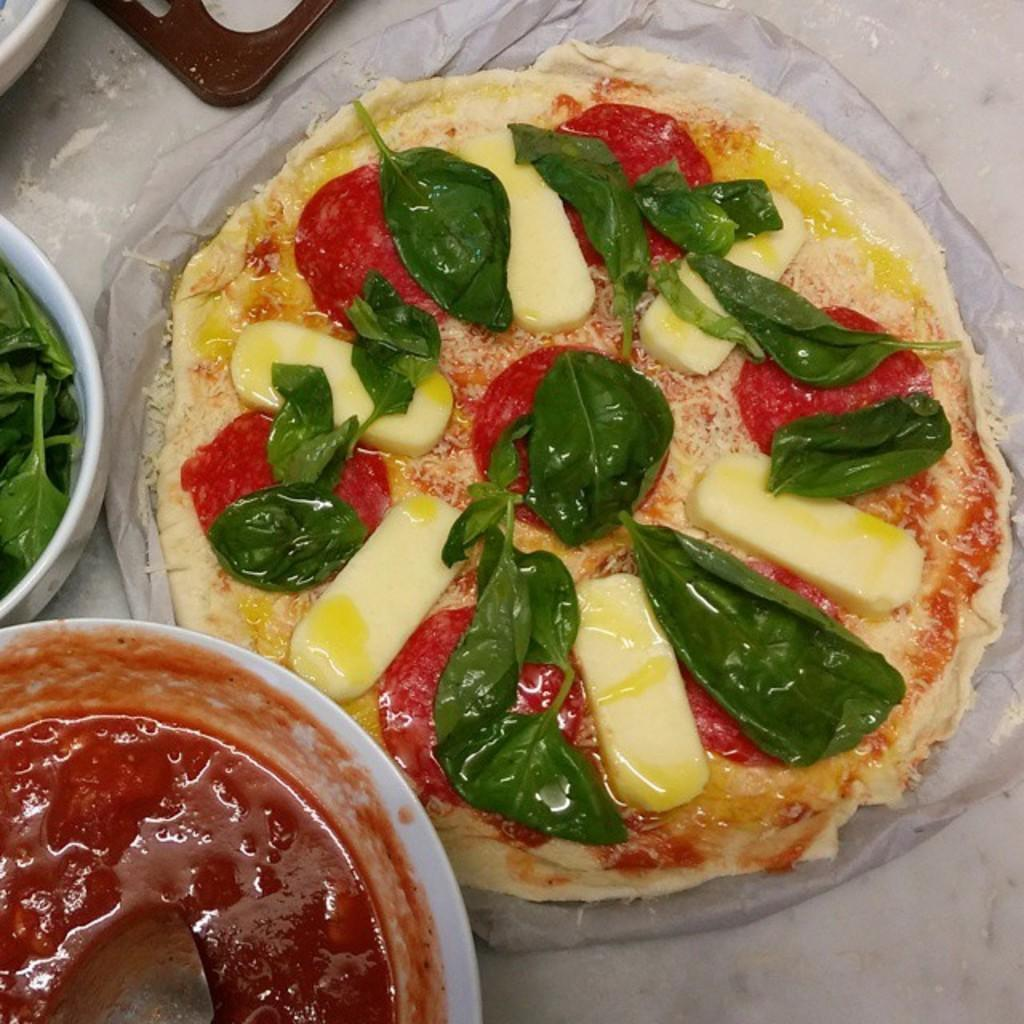What is in the bowl that is visible in the image? There are food items in a bowl in the image. What type of food can be seen in the image besides the food in the bowl? There is a pizza in the image. What is located on the floor in front of the pizza? There is an object on the floor in front of the pizza. Can you see a trail of ladybugs leading up to the pizza in the image? There are no ladybugs or trails visible in the image. 